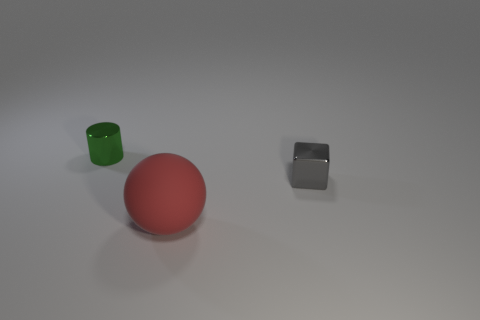Add 3 small blue cylinders. How many objects exist? 6 Subtract all cylinders. How many objects are left? 2 Add 1 rubber spheres. How many rubber spheres are left? 2 Add 3 small green shiny objects. How many small green shiny objects exist? 4 Subtract 0 red cubes. How many objects are left? 3 Subtract all brown cylinders. Subtract all blue cubes. How many cylinders are left? 1 Subtract all shiny cylinders. Subtract all green metal objects. How many objects are left? 1 